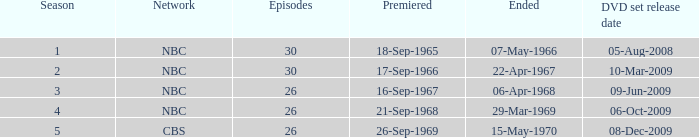What is the total season number for episodes later than episode 30? None. 